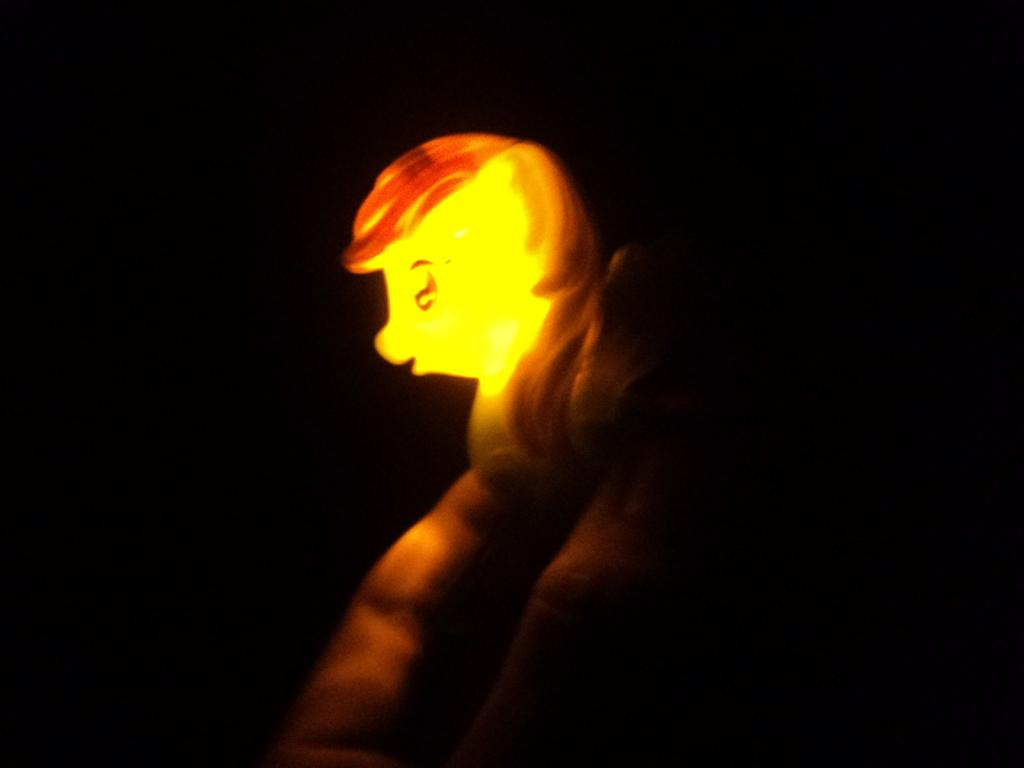What is the main subject of the image? There is a person in the image. What is the person holding in the image? The person is holding a toy. Can you describe the light source in the image? Light is coming from the person or the toy. How many sticks are being used by the chickens in the image? There are no chickens or sticks present in the image. What type of rice is being served in the image? There is no rice present in the image. 